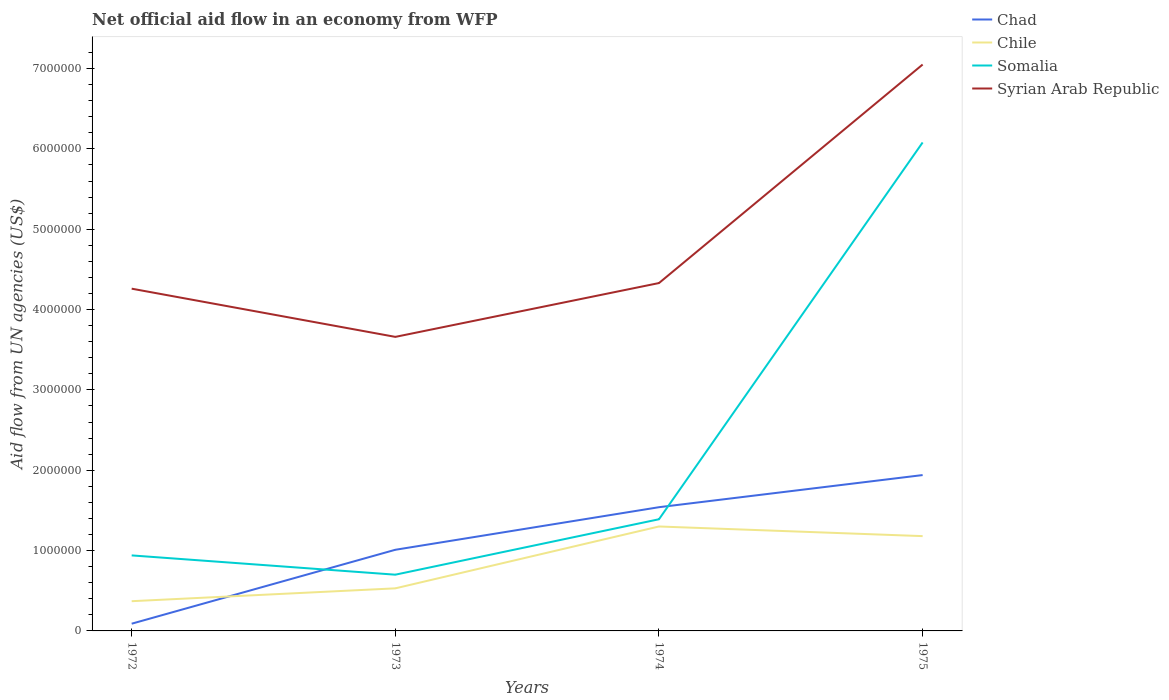Does the line corresponding to Syrian Arab Republic intersect with the line corresponding to Chad?
Give a very brief answer. No. Is the number of lines equal to the number of legend labels?
Ensure brevity in your answer.  Yes. Across all years, what is the maximum net official aid flow in Syrian Arab Republic?
Your answer should be very brief. 3.66e+06. What is the total net official aid flow in Chile in the graph?
Ensure brevity in your answer.  -6.50e+05. What is the difference between the highest and the second highest net official aid flow in Syrian Arab Republic?
Keep it short and to the point. 3.39e+06. What is the difference between the highest and the lowest net official aid flow in Syrian Arab Republic?
Provide a short and direct response. 1. How many lines are there?
Offer a terse response. 4. Are the values on the major ticks of Y-axis written in scientific E-notation?
Provide a short and direct response. No. What is the title of the graph?
Your response must be concise. Net official aid flow in an economy from WFP. Does "Europe(developing only)" appear as one of the legend labels in the graph?
Make the answer very short. No. What is the label or title of the X-axis?
Give a very brief answer. Years. What is the label or title of the Y-axis?
Make the answer very short. Aid flow from UN agencies (US$). What is the Aid flow from UN agencies (US$) of Chad in 1972?
Your answer should be very brief. 9.00e+04. What is the Aid flow from UN agencies (US$) in Somalia in 1972?
Provide a short and direct response. 9.40e+05. What is the Aid flow from UN agencies (US$) of Syrian Arab Republic in 1972?
Offer a very short reply. 4.26e+06. What is the Aid flow from UN agencies (US$) in Chad in 1973?
Offer a terse response. 1.01e+06. What is the Aid flow from UN agencies (US$) of Chile in 1973?
Keep it short and to the point. 5.30e+05. What is the Aid flow from UN agencies (US$) of Somalia in 1973?
Give a very brief answer. 7.00e+05. What is the Aid flow from UN agencies (US$) in Syrian Arab Republic in 1973?
Your answer should be very brief. 3.66e+06. What is the Aid flow from UN agencies (US$) in Chad in 1974?
Keep it short and to the point. 1.54e+06. What is the Aid flow from UN agencies (US$) of Chile in 1974?
Your response must be concise. 1.30e+06. What is the Aid flow from UN agencies (US$) of Somalia in 1974?
Give a very brief answer. 1.39e+06. What is the Aid flow from UN agencies (US$) of Syrian Arab Republic in 1974?
Give a very brief answer. 4.33e+06. What is the Aid flow from UN agencies (US$) in Chad in 1975?
Your answer should be very brief. 1.94e+06. What is the Aid flow from UN agencies (US$) of Chile in 1975?
Your answer should be compact. 1.18e+06. What is the Aid flow from UN agencies (US$) of Somalia in 1975?
Make the answer very short. 6.08e+06. What is the Aid flow from UN agencies (US$) in Syrian Arab Republic in 1975?
Offer a terse response. 7.05e+06. Across all years, what is the maximum Aid flow from UN agencies (US$) of Chad?
Offer a terse response. 1.94e+06. Across all years, what is the maximum Aid flow from UN agencies (US$) in Chile?
Make the answer very short. 1.30e+06. Across all years, what is the maximum Aid flow from UN agencies (US$) of Somalia?
Give a very brief answer. 6.08e+06. Across all years, what is the maximum Aid flow from UN agencies (US$) of Syrian Arab Republic?
Make the answer very short. 7.05e+06. Across all years, what is the minimum Aid flow from UN agencies (US$) of Chad?
Your answer should be very brief. 9.00e+04. Across all years, what is the minimum Aid flow from UN agencies (US$) of Chile?
Provide a succinct answer. 3.70e+05. Across all years, what is the minimum Aid flow from UN agencies (US$) of Syrian Arab Republic?
Make the answer very short. 3.66e+06. What is the total Aid flow from UN agencies (US$) of Chad in the graph?
Give a very brief answer. 4.58e+06. What is the total Aid flow from UN agencies (US$) in Chile in the graph?
Ensure brevity in your answer.  3.38e+06. What is the total Aid flow from UN agencies (US$) of Somalia in the graph?
Make the answer very short. 9.11e+06. What is the total Aid flow from UN agencies (US$) in Syrian Arab Republic in the graph?
Your answer should be very brief. 1.93e+07. What is the difference between the Aid flow from UN agencies (US$) in Chad in 1972 and that in 1973?
Provide a succinct answer. -9.20e+05. What is the difference between the Aid flow from UN agencies (US$) in Chile in 1972 and that in 1973?
Your answer should be very brief. -1.60e+05. What is the difference between the Aid flow from UN agencies (US$) in Somalia in 1972 and that in 1973?
Give a very brief answer. 2.40e+05. What is the difference between the Aid flow from UN agencies (US$) in Syrian Arab Republic in 1972 and that in 1973?
Give a very brief answer. 6.00e+05. What is the difference between the Aid flow from UN agencies (US$) in Chad in 1972 and that in 1974?
Your answer should be very brief. -1.45e+06. What is the difference between the Aid flow from UN agencies (US$) of Chile in 1972 and that in 1974?
Offer a terse response. -9.30e+05. What is the difference between the Aid flow from UN agencies (US$) in Somalia in 1972 and that in 1974?
Ensure brevity in your answer.  -4.50e+05. What is the difference between the Aid flow from UN agencies (US$) of Chad in 1972 and that in 1975?
Offer a very short reply. -1.85e+06. What is the difference between the Aid flow from UN agencies (US$) in Chile in 1972 and that in 1975?
Provide a succinct answer. -8.10e+05. What is the difference between the Aid flow from UN agencies (US$) in Somalia in 1972 and that in 1975?
Offer a terse response. -5.14e+06. What is the difference between the Aid flow from UN agencies (US$) in Syrian Arab Republic in 1972 and that in 1975?
Your answer should be very brief. -2.79e+06. What is the difference between the Aid flow from UN agencies (US$) in Chad in 1973 and that in 1974?
Your response must be concise. -5.30e+05. What is the difference between the Aid flow from UN agencies (US$) in Chile in 1973 and that in 1974?
Your answer should be compact. -7.70e+05. What is the difference between the Aid flow from UN agencies (US$) of Somalia in 1973 and that in 1974?
Provide a short and direct response. -6.90e+05. What is the difference between the Aid flow from UN agencies (US$) in Syrian Arab Republic in 1973 and that in 1974?
Give a very brief answer. -6.70e+05. What is the difference between the Aid flow from UN agencies (US$) of Chad in 1973 and that in 1975?
Your answer should be very brief. -9.30e+05. What is the difference between the Aid flow from UN agencies (US$) in Chile in 1973 and that in 1975?
Make the answer very short. -6.50e+05. What is the difference between the Aid flow from UN agencies (US$) of Somalia in 1973 and that in 1975?
Provide a succinct answer. -5.38e+06. What is the difference between the Aid flow from UN agencies (US$) of Syrian Arab Republic in 1973 and that in 1975?
Make the answer very short. -3.39e+06. What is the difference between the Aid flow from UN agencies (US$) in Chad in 1974 and that in 1975?
Provide a succinct answer. -4.00e+05. What is the difference between the Aid flow from UN agencies (US$) in Somalia in 1974 and that in 1975?
Give a very brief answer. -4.69e+06. What is the difference between the Aid flow from UN agencies (US$) in Syrian Arab Republic in 1974 and that in 1975?
Your answer should be very brief. -2.72e+06. What is the difference between the Aid flow from UN agencies (US$) in Chad in 1972 and the Aid flow from UN agencies (US$) in Chile in 1973?
Keep it short and to the point. -4.40e+05. What is the difference between the Aid flow from UN agencies (US$) in Chad in 1972 and the Aid flow from UN agencies (US$) in Somalia in 1973?
Your answer should be compact. -6.10e+05. What is the difference between the Aid flow from UN agencies (US$) in Chad in 1972 and the Aid flow from UN agencies (US$) in Syrian Arab Republic in 1973?
Offer a very short reply. -3.57e+06. What is the difference between the Aid flow from UN agencies (US$) in Chile in 1972 and the Aid flow from UN agencies (US$) in Somalia in 1973?
Provide a short and direct response. -3.30e+05. What is the difference between the Aid flow from UN agencies (US$) of Chile in 1972 and the Aid flow from UN agencies (US$) of Syrian Arab Republic in 1973?
Your response must be concise. -3.29e+06. What is the difference between the Aid flow from UN agencies (US$) of Somalia in 1972 and the Aid flow from UN agencies (US$) of Syrian Arab Republic in 1973?
Keep it short and to the point. -2.72e+06. What is the difference between the Aid flow from UN agencies (US$) in Chad in 1972 and the Aid flow from UN agencies (US$) in Chile in 1974?
Your response must be concise. -1.21e+06. What is the difference between the Aid flow from UN agencies (US$) of Chad in 1972 and the Aid flow from UN agencies (US$) of Somalia in 1974?
Offer a very short reply. -1.30e+06. What is the difference between the Aid flow from UN agencies (US$) of Chad in 1972 and the Aid flow from UN agencies (US$) of Syrian Arab Republic in 1974?
Ensure brevity in your answer.  -4.24e+06. What is the difference between the Aid flow from UN agencies (US$) in Chile in 1972 and the Aid flow from UN agencies (US$) in Somalia in 1974?
Provide a short and direct response. -1.02e+06. What is the difference between the Aid flow from UN agencies (US$) of Chile in 1972 and the Aid flow from UN agencies (US$) of Syrian Arab Republic in 1974?
Offer a very short reply. -3.96e+06. What is the difference between the Aid flow from UN agencies (US$) of Somalia in 1972 and the Aid flow from UN agencies (US$) of Syrian Arab Republic in 1974?
Your response must be concise. -3.39e+06. What is the difference between the Aid flow from UN agencies (US$) in Chad in 1972 and the Aid flow from UN agencies (US$) in Chile in 1975?
Your answer should be very brief. -1.09e+06. What is the difference between the Aid flow from UN agencies (US$) in Chad in 1972 and the Aid flow from UN agencies (US$) in Somalia in 1975?
Give a very brief answer. -5.99e+06. What is the difference between the Aid flow from UN agencies (US$) of Chad in 1972 and the Aid flow from UN agencies (US$) of Syrian Arab Republic in 1975?
Your answer should be compact. -6.96e+06. What is the difference between the Aid flow from UN agencies (US$) in Chile in 1972 and the Aid flow from UN agencies (US$) in Somalia in 1975?
Your answer should be compact. -5.71e+06. What is the difference between the Aid flow from UN agencies (US$) of Chile in 1972 and the Aid flow from UN agencies (US$) of Syrian Arab Republic in 1975?
Your answer should be very brief. -6.68e+06. What is the difference between the Aid flow from UN agencies (US$) of Somalia in 1972 and the Aid flow from UN agencies (US$) of Syrian Arab Republic in 1975?
Your response must be concise. -6.11e+06. What is the difference between the Aid flow from UN agencies (US$) in Chad in 1973 and the Aid flow from UN agencies (US$) in Somalia in 1974?
Your answer should be very brief. -3.80e+05. What is the difference between the Aid flow from UN agencies (US$) in Chad in 1973 and the Aid flow from UN agencies (US$) in Syrian Arab Republic in 1974?
Provide a succinct answer. -3.32e+06. What is the difference between the Aid flow from UN agencies (US$) in Chile in 1973 and the Aid flow from UN agencies (US$) in Somalia in 1974?
Provide a succinct answer. -8.60e+05. What is the difference between the Aid flow from UN agencies (US$) of Chile in 1973 and the Aid flow from UN agencies (US$) of Syrian Arab Republic in 1974?
Provide a succinct answer. -3.80e+06. What is the difference between the Aid flow from UN agencies (US$) in Somalia in 1973 and the Aid flow from UN agencies (US$) in Syrian Arab Republic in 1974?
Provide a short and direct response. -3.63e+06. What is the difference between the Aid flow from UN agencies (US$) of Chad in 1973 and the Aid flow from UN agencies (US$) of Chile in 1975?
Offer a terse response. -1.70e+05. What is the difference between the Aid flow from UN agencies (US$) of Chad in 1973 and the Aid flow from UN agencies (US$) of Somalia in 1975?
Make the answer very short. -5.07e+06. What is the difference between the Aid flow from UN agencies (US$) of Chad in 1973 and the Aid flow from UN agencies (US$) of Syrian Arab Republic in 1975?
Make the answer very short. -6.04e+06. What is the difference between the Aid flow from UN agencies (US$) in Chile in 1973 and the Aid flow from UN agencies (US$) in Somalia in 1975?
Give a very brief answer. -5.55e+06. What is the difference between the Aid flow from UN agencies (US$) in Chile in 1973 and the Aid flow from UN agencies (US$) in Syrian Arab Republic in 1975?
Provide a succinct answer. -6.52e+06. What is the difference between the Aid flow from UN agencies (US$) in Somalia in 1973 and the Aid flow from UN agencies (US$) in Syrian Arab Republic in 1975?
Your response must be concise. -6.35e+06. What is the difference between the Aid flow from UN agencies (US$) of Chad in 1974 and the Aid flow from UN agencies (US$) of Somalia in 1975?
Provide a short and direct response. -4.54e+06. What is the difference between the Aid flow from UN agencies (US$) of Chad in 1974 and the Aid flow from UN agencies (US$) of Syrian Arab Republic in 1975?
Ensure brevity in your answer.  -5.51e+06. What is the difference between the Aid flow from UN agencies (US$) in Chile in 1974 and the Aid flow from UN agencies (US$) in Somalia in 1975?
Give a very brief answer. -4.78e+06. What is the difference between the Aid flow from UN agencies (US$) in Chile in 1974 and the Aid flow from UN agencies (US$) in Syrian Arab Republic in 1975?
Your answer should be very brief. -5.75e+06. What is the difference between the Aid flow from UN agencies (US$) of Somalia in 1974 and the Aid flow from UN agencies (US$) of Syrian Arab Republic in 1975?
Your answer should be compact. -5.66e+06. What is the average Aid flow from UN agencies (US$) in Chad per year?
Give a very brief answer. 1.14e+06. What is the average Aid flow from UN agencies (US$) of Chile per year?
Give a very brief answer. 8.45e+05. What is the average Aid flow from UN agencies (US$) in Somalia per year?
Keep it short and to the point. 2.28e+06. What is the average Aid flow from UN agencies (US$) of Syrian Arab Republic per year?
Offer a terse response. 4.82e+06. In the year 1972, what is the difference between the Aid flow from UN agencies (US$) in Chad and Aid flow from UN agencies (US$) in Chile?
Give a very brief answer. -2.80e+05. In the year 1972, what is the difference between the Aid flow from UN agencies (US$) of Chad and Aid flow from UN agencies (US$) of Somalia?
Provide a short and direct response. -8.50e+05. In the year 1972, what is the difference between the Aid flow from UN agencies (US$) in Chad and Aid flow from UN agencies (US$) in Syrian Arab Republic?
Give a very brief answer. -4.17e+06. In the year 1972, what is the difference between the Aid flow from UN agencies (US$) in Chile and Aid flow from UN agencies (US$) in Somalia?
Your answer should be compact. -5.70e+05. In the year 1972, what is the difference between the Aid flow from UN agencies (US$) of Chile and Aid flow from UN agencies (US$) of Syrian Arab Republic?
Your answer should be compact. -3.89e+06. In the year 1972, what is the difference between the Aid flow from UN agencies (US$) in Somalia and Aid flow from UN agencies (US$) in Syrian Arab Republic?
Keep it short and to the point. -3.32e+06. In the year 1973, what is the difference between the Aid flow from UN agencies (US$) in Chad and Aid flow from UN agencies (US$) in Chile?
Provide a succinct answer. 4.80e+05. In the year 1973, what is the difference between the Aid flow from UN agencies (US$) of Chad and Aid flow from UN agencies (US$) of Somalia?
Offer a very short reply. 3.10e+05. In the year 1973, what is the difference between the Aid flow from UN agencies (US$) of Chad and Aid flow from UN agencies (US$) of Syrian Arab Republic?
Your answer should be very brief. -2.65e+06. In the year 1973, what is the difference between the Aid flow from UN agencies (US$) in Chile and Aid flow from UN agencies (US$) in Syrian Arab Republic?
Offer a very short reply. -3.13e+06. In the year 1973, what is the difference between the Aid flow from UN agencies (US$) of Somalia and Aid flow from UN agencies (US$) of Syrian Arab Republic?
Offer a very short reply. -2.96e+06. In the year 1974, what is the difference between the Aid flow from UN agencies (US$) in Chad and Aid flow from UN agencies (US$) in Chile?
Offer a very short reply. 2.40e+05. In the year 1974, what is the difference between the Aid flow from UN agencies (US$) of Chad and Aid flow from UN agencies (US$) of Somalia?
Provide a short and direct response. 1.50e+05. In the year 1974, what is the difference between the Aid flow from UN agencies (US$) in Chad and Aid flow from UN agencies (US$) in Syrian Arab Republic?
Ensure brevity in your answer.  -2.79e+06. In the year 1974, what is the difference between the Aid flow from UN agencies (US$) in Chile and Aid flow from UN agencies (US$) in Somalia?
Your answer should be compact. -9.00e+04. In the year 1974, what is the difference between the Aid flow from UN agencies (US$) of Chile and Aid flow from UN agencies (US$) of Syrian Arab Republic?
Offer a very short reply. -3.03e+06. In the year 1974, what is the difference between the Aid flow from UN agencies (US$) of Somalia and Aid flow from UN agencies (US$) of Syrian Arab Republic?
Ensure brevity in your answer.  -2.94e+06. In the year 1975, what is the difference between the Aid flow from UN agencies (US$) in Chad and Aid flow from UN agencies (US$) in Chile?
Make the answer very short. 7.60e+05. In the year 1975, what is the difference between the Aid flow from UN agencies (US$) in Chad and Aid flow from UN agencies (US$) in Somalia?
Your answer should be very brief. -4.14e+06. In the year 1975, what is the difference between the Aid flow from UN agencies (US$) in Chad and Aid flow from UN agencies (US$) in Syrian Arab Republic?
Provide a succinct answer. -5.11e+06. In the year 1975, what is the difference between the Aid flow from UN agencies (US$) of Chile and Aid flow from UN agencies (US$) of Somalia?
Provide a short and direct response. -4.90e+06. In the year 1975, what is the difference between the Aid flow from UN agencies (US$) of Chile and Aid flow from UN agencies (US$) of Syrian Arab Republic?
Your answer should be compact. -5.87e+06. In the year 1975, what is the difference between the Aid flow from UN agencies (US$) in Somalia and Aid flow from UN agencies (US$) in Syrian Arab Republic?
Provide a short and direct response. -9.70e+05. What is the ratio of the Aid flow from UN agencies (US$) of Chad in 1972 to that in 1973?
Your answer should be compact. 0.09. What is the ratio of the Aid flow from UN agencies (US$) of Chile in 1972 to that in 1973?
Offer a very short reply. 0.7. What is the ratio of the Aid flow from UN agencies (US$) of Somalia in 1972 to that in 1973?
Provide a succinct answer. 1.34. What is the ratio of the Aid flow from UN agencies (US$) of Syrian Arab Republic in 1972 to that in 1973?
Offer a terse response. 1.16. What is the ratio of the Aid flow from UN agencies (US$) of Chad in 1972 to that in 1974?
Your answer should be very brief. 0.06. What is the ratio of the Aid flow from UN agencies (US$) in Chile in 1972 to that in 1974?
Give a very brief answer. 0.28. What is the ratio of the Aid flow from UN agencies (US$) of Somalia in 1972 to that in 1974?
Provide a short and direct response. 0.68. What is the ratio of the Aid flow from UN agencies (US$) in Syrian Arab Republic in 1972 to that in 1974?
Ensure brevity in your answer.  0.98. What is the ratio of the Aid flow from UN agencies (US$) of Chad in 1972 to that in 1975?
Your answer should be compact. 0.05. What is the ratio of the Aid flow from UN agencies (US$) of Chile in 1972 to that in 1975?
Offer a terse response. 0.31. What is the ratio of the Aid flow from UN agencies (US$) in Somalia in 1972 to that in 1975?
Offer a terse response. 0.15. What is the ratio of the Aid flow from UN agencies (US$) in Syrian Arab Republic in 1972 to that in 1975?
Offer a terse response. 0.6. What is the ratio of the Aid flow from UN agencies (US$) in Chad in 1973 to that in 1974?
Your answer should be compact. 0.66. What is the ratio of the Aid flow from UN agencies (US$) in Chile in 1973 to that in 1974?
Keep it short and to the point. 0.41. What is the ratio of the Aid flow from UN agencies (US$) in Somalia in 1973 to that in 1974?
Your answer should be very brief. 0.5. What is the ratio of the Aid flow from UN agencies (US$) in Syrian Arab Republic in 1973 to that in 1974?
Offer a terse response. 0.85. What is the ratio of the Aid flow from UN agencies (US$) in Chad in 1973 to that in 1975?
Ensure brevity in your answer.  0.52. What is the ratio of the Aid flow from UN agencies (US$) of Chile in 1973 to that in 1975?
Make the answer very short. 0.45. What is the ratio of the Aid flow from UN agencies (US$) of Somalia in 1973 to that in 1975?
Keep it short and to the point. 0.12. What is the ratio of the Aid flow from UN agencies (US$) of Syrian Arab Republic in 1973 to that in 1975?
Offer a terse response. 0.52. What is the ratio of the Aid flow from UN agencies (US$) in Chad in 1974 to that in 1975?
Your answer should be compact. 0.79. What is the ratio of the Aid flow from UN agencies (US$) in Chile in 1974 to that in 1975?
Keep it short and to the point. 1.1. What is the ratio of the Aid flow from UN agencies (US$) of Somalia in 1974 to that in 1975?
Your answer should be very brief. 0.23. What is the ratio of the Aid flow from UN agencies (US$) in Syrian Arab Republic in 1974 to that in 1975?
Provide a succinct answer. 0.61. What is the difference between the highest and the second highest Aid flow from UN agencies (US$) in Chile?
Your response must be concise. 1.20e+05. What is the difference between the highest and the second highest Aid flow from UN agencies (US$) of Somalia?
Make the answer very short. 4.69e+06. What is the difference between the highest and the second highest Aid flow from UN agencies (US$) of Syrian Arab Republic?
Your response must be concise. 2.72e+06. What is the difference between the highest and the lowest Aid flow from UN agencies (US$) in Chad?
Provide a short and direct response. 1.85e+06. What is the difference between the highest and the lowest Aid flow from UN agencies (US$) of Chile?
Give a very brief answer. 9.30e+05. What is the difference between the highest and the lowest Aid flow from UN agencies (US$) in Somalia?
Give a very brief answer. 5.38e+06. What is the difference between the highest and the lowest Aid flow from UN agencies (US$) in Syrian Arab Republic?
Provide a succinct answer. 3.39e+06. 